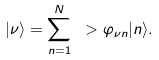Convert formula to latex. <formula><loc_0><loc_0><loc_500><loc_500>| \nu \rangle = \sum _ { n = 1 } ^ { N } \ > \varphi _ { \nu n } | n \rangle .</formula> 